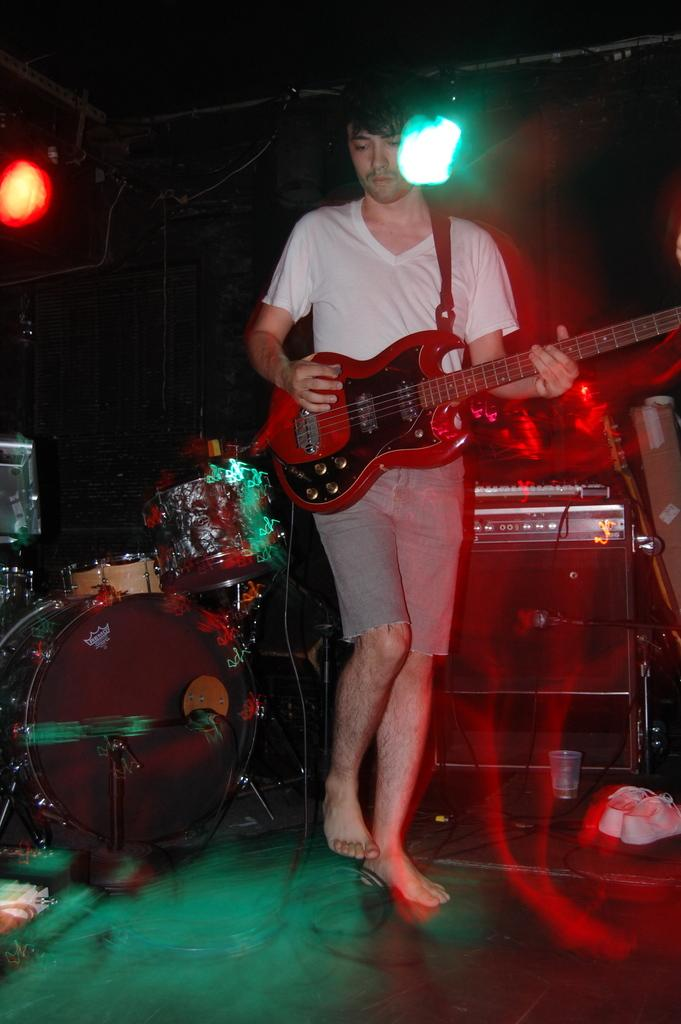What is the main subject of the image? The main subject of the image is a man. What is the man doing in the image? The man is standing and playing a guitar. Are there any other musical instruments visible in the image? Yes, there are drums visible in the image. How many wheels can be seen on the house in the image? There is no house present in the image, and therefore no wheels can be seen. 